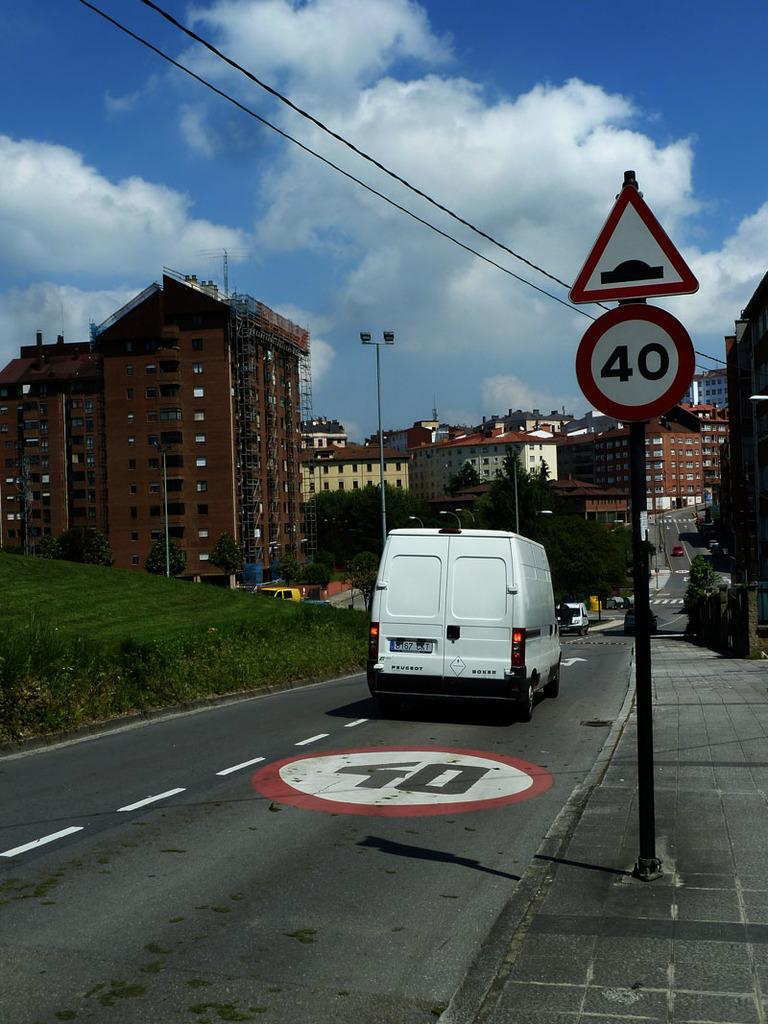Provide a one-sentence caption for the provided image. White van in the fourty lane that is headed to the end of the street. 